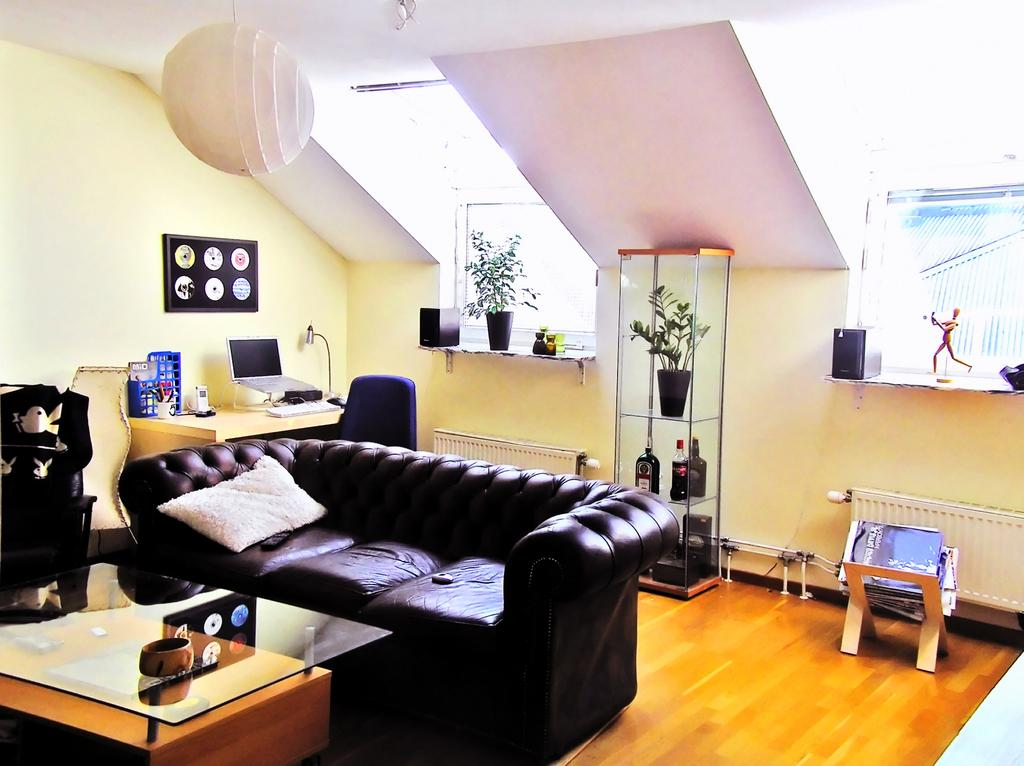What type of furniture is in the image? There is a couch and a chair in the image. What is placed in front of the couch? There is a table in front of the couch. What celestial objects are present in the image? There are planets placed in the image. What electronic device can be seen in the image? There is a laptop in the image. What type of wrench is being used to fix the planets in the image? There is no wrench present in the image, and the planets are not being fixed. What type of love is being expressed between the planets in the image? There is no indication of love or any emotional connection between the planets in the image. 